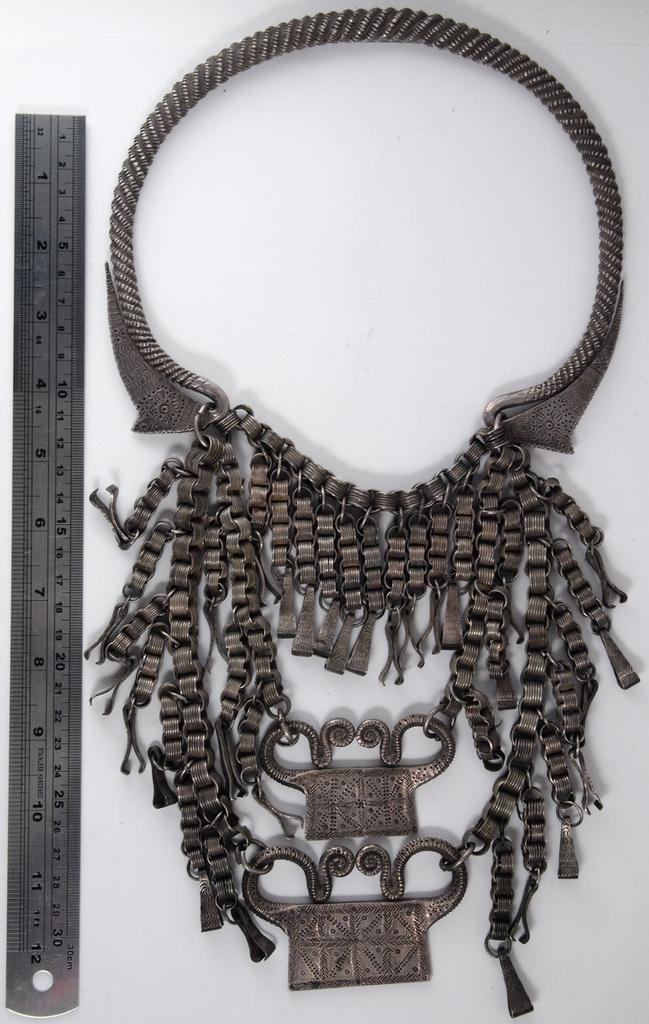What object can be seen in the image that is used for measuring weight? There is a scale in the image that is used for measuring weight. What other object is present beside the scale in the image? There is an ornament beside the scale in the image. How many bees can be seen flying around the scale in the image? There are no bees present in the image. What page of a book is visible in the image? There is no book or page present in the image. 